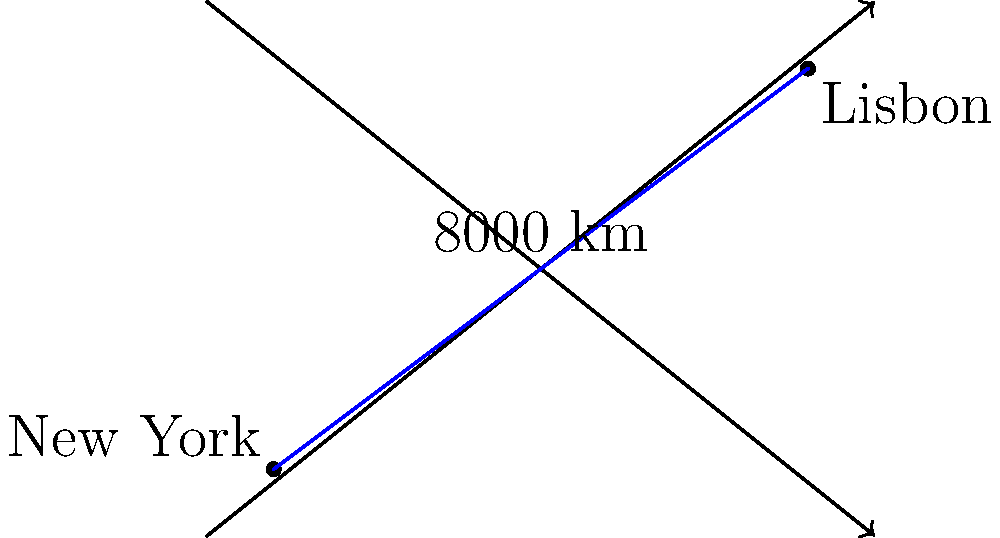You're planning a transatlantic voyage from New York to Lisbon. On your nautical chart, the distance between these two ports is represented by a line segment measuring 8 cm. If the scale of the chart is 1 cm : 1000 km, what is the actual distance between New York and Lisbon? To solve this problem, we'll follow these steps:

1. Understand the given information:
   * The distance on the chart is 8 cm
   * The scale is 1 cm : 1000 km

2. Set up a proportion to relate the chart distance to the actual distance:
   $\frac{1 \text{ cm}}{1000 \text{ km}} = \frac{8 \text{ cm}}{x \text{ km}}$

3. Cross multiply to solve for x:
   $1 \cdot x = 1000 \cdot 8$
   $x = 8000$

4. Therefore, the actual distance is 8000 km.

This calculation demonstrates how we can use a map's scale to convert distances on a chart to real-world distances, an essential skill for navigation and voyage planning.
Answer: 8000 km 